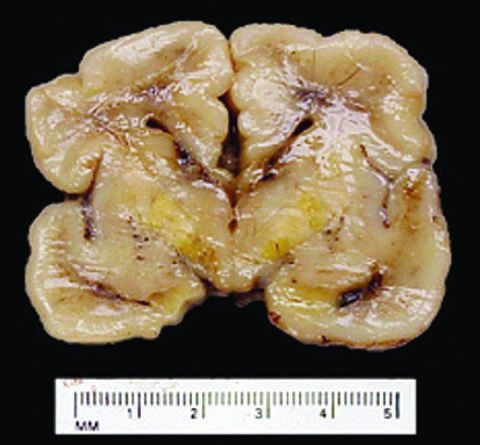does this occur because the blood-brain barrier is less developed in the neonatal period than it is in adulthood?
Answer the question using a single word or phrase. Yes 